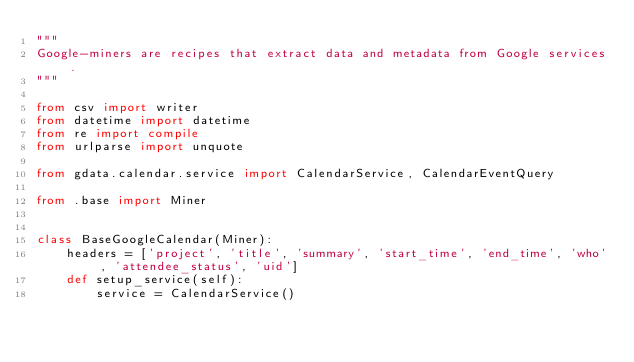Convert code to text. <code><loc_0><loc_0><loc_500><loc_500><_Python_>"""
Google-miners are recipes that extract data and metadata from Google services.
"""

from csv import writer
from datetime import datetime
from re import compile
from urlparse import unquote

from gdata.calendar.service import CalendarService, CalendarEventQuery

from .base import Miner


class BaseGoogleCalendar(Miner):
    headers = ['project', 'title', 'summary', 'start_time', 'end_time', 'who', 'attendee_status', 'uid']
    def setup_service(self):
        service = CalendarService()</code> 